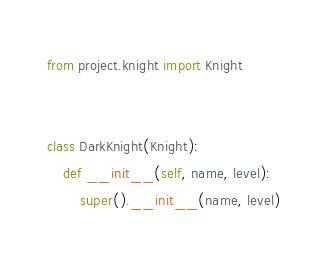Convert code to text. <code><loc_0><loc_0><loc_500><loc_500><_Python_>from project.knight import Knight


class DarkKnight(Knight):
    def __init__(self, name, level):
        super().__init__(name, level)
</code> 